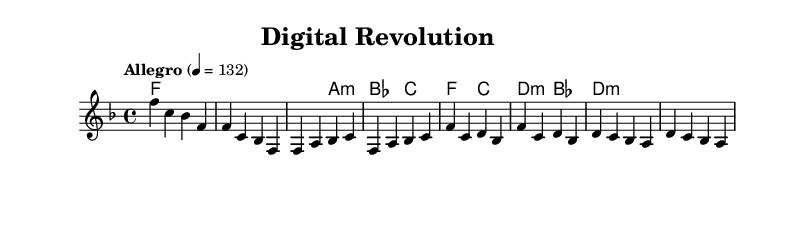What is the key signature of this music? The key signature shows one flat (B♭) at the beginning of the staff, which indicates that the piece is in F major.
Answer: F major What is the time signature? The time signature is indicated by the fraction displayed at the beginning of the staff; it shows 4 beats per measure, which is noted as 4/4.
Answer: 4/4 What is the tempo marking of the piece? The tempo marking at the beginning indicates the speed of the piece, which in this case is "Allegro" at 132 beats per minute.
Answer: Allegro, 132 How many measures are in the intro section? By counting the measures in the intro section indicated at the start of the piece, there are a total of 2 measures.
Answer: 2 Which chord appears most frequently in the first verse? The chord progression of the verse shows that F major appears consistently throughout, making it the most frequently listed chord.
Answer: F major What is the dynamic level indicated for the chorus section? The absence of any dynamic markings suggests that the chorus maintains a typical volume level, which in this context can often be interpreted as "moderate."
Answer: Moderate In which section does the tempo change from the intro? The tempo remains consistent throughout the intro and the first verse, with no changes noted in either section, so the answer would reflect that no actual change occurs until the following sections are reached.
Answer: No change 